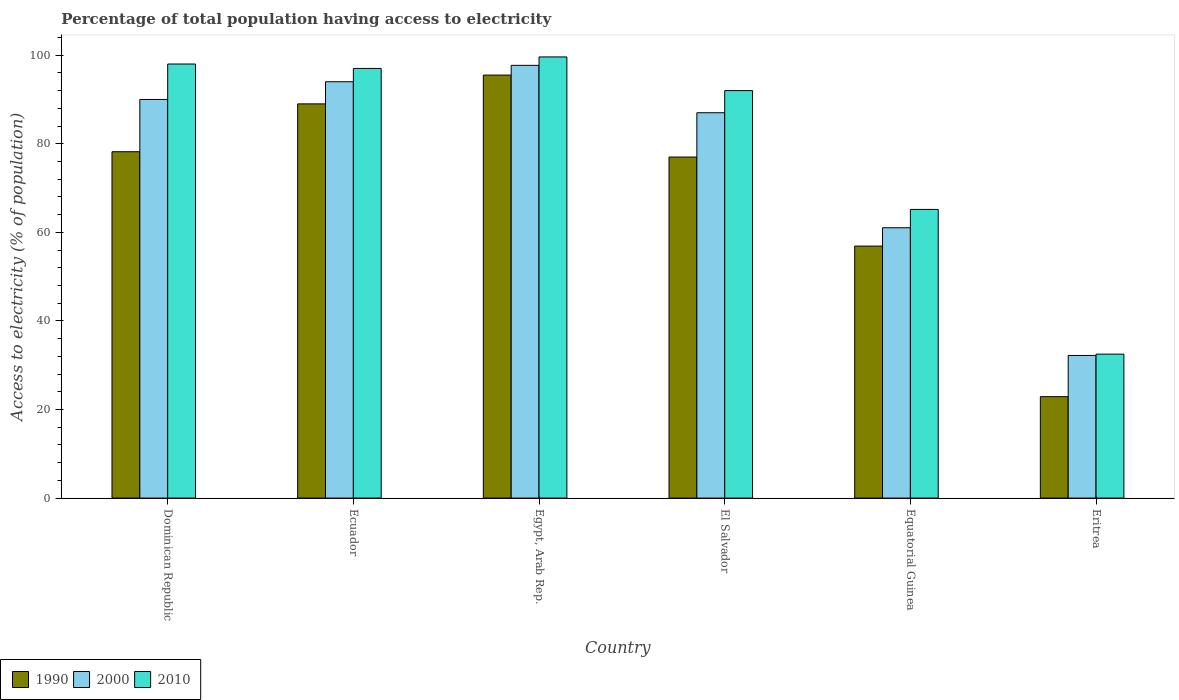How many different coloured bars are there?
Provide a succinct answer. 3. How many groups of bars are there?
Give a very brief answer. 6. Are the number of bars per tick equal to the number of legend labels?
Give a very brief answer. Yes. Are the number of bars on each tick of the X-axis equal?
Your response must be concise. Yes. How many bars are there on the 4th tick from the left?
Give a very brief answer. 3. How many bars are there on the 3rd tick from the right?
Keep it short and to the point. 3. What is the label of the 6th group of bars from the left?
Provide a short and direct response. Eritrea. In how many cases, is the number of bars for a given country not equal to the number of legend labels?
Make the answer very short. 0. What is the percentage of population that have access to electricity in 2010 in Eritrea?
Offer a terse response. 32.5. Across all countries, what is the maximum percentage of population that have access to electricity in 2000?
Keep it short and to the point. 97.7. Across all countries, what is the minimum percentage of population that have access to electricity in 1990?
Ensure brevity in your answer.  22.9. In which country was the percentage of population that have access to electricity in 2000 maximum?
Make the answer very short. Egypt, Arab Rep. In which country was the percentage of population that have access to electricity in 2010 minimum?
Your answer should be compact. Eritrea. What is the total percentage of population that have access to electricity in 2010 in the graph?
Ensure brevity in your answer.  484.27. What is the difference between the percentage of population that have access to electricity in 2000 in Dominican Republic and that in Equatorial Guinea?
Offer a very short reply. 28.97. What is the average percentage of population that have access to electricity in 2010 per country?
Offer a very short reply. 80.71. What is the difference between the percentage of population that have access to electricity of/in 2000 and percentage of population that have access to electricity of/in 1990 in El Salvador?
Give a very brief answer. 10. What is the ratio of the percentage of population that have access to electricity in 2000 in El Salvador to that in Eritrea?
Make the answer very short. 2.7. Is the percentage of population that have access to electricity in 2000 in Egypt, Arab Rep. less than that in Eritrea?
Provide a succinct answer. No. What is the difference between the highest and the second highest percentage of population that have access to electricity in 2000?
Keep it short and to the point. 7.7. What is the difference between the highest and the lowest percentage of population that have access to electricity in 1990?
Keep it short and to the point. 72.6. In how many countries, is the percentage of population that have access to electricity in 2010 greater than the average percentage of population that have access to electricity in 2010 taken over all countries?
Your answer should be compact. 4. How many bars are there?
Offer a very short reply. 18. How many countries are there in the graph?
Offer a very short reply. 6. What is the difference between two consecutive major ticks on the Y-axis?
Make the answer very short. 20. Does the graph contain any zero values?
Your response must be concise. No. How many legend labels are there?
Provide a short and direct response. 3. How are the legend labels stacked?
Ensure brevity in your answer.  Horizontal. What is the title of the graph?
Offer a very short reply. Percentage of total population having access to electricity. Does "2007" appear as one of the legend labels in the graph?
Your response must be concise. No. What is the label or title of the Y-axis?
Make the answer very short. Access to electricity (% of population). What is the Access to electricity (% of population) of 1990 in Dominican Republic?
Make the answer very short. 78.2. What is the Access to electricity (% of population) of 1990 in Ecuador?
Keep it short and to the point. 89. What is the Access to electricity (% of population) of 2000 in Ecuador?
Provide a short and direct response. 94. What is the Access to electricity (% of population) of 2010 in Ecuador?
Ensure brevity in your answer.  97. What is the Access to electricity (% of population) in 1990 in Egypt, Arab Rep.?
Ensure brevity in your answer.  95.5. What is the Access to electricity (% of population) of 2000 in Egypt, Arab Rep.?
Ensure brevity in your answer.  97.7. What is the Access to electricity (% of population) in 2010 in Egypt, Arab Rep.?
Ensure brevity in your answer.  99.6. What is the Access to electricity (% of population) in 1990 in El Salvador?
Offer a very short reply. 77. What is the Access to electricity (% of population) in 2000 in El Salvador?
Offer a terse response. 87. What is the Access to electricity (% of population) of 2010 in El Salvador?
Make the answer very short. 92. What is the Access to electricity (% of population) of 1990 in Equatorial Guinea?
Your answer should be compact. 56.89. What is the Access to electricity (% of population) in 2000 in Equatorial Guinea?
Ensure brevity in your answer.  61.03. What is the Access to electricity (% of population) of 2010 in Equatorial Guinea?
Make the answer very short. 65.17. What is the Access to electricity (% of population) of 1990 in Eritrea?
Your answer should be very brief. 22.9. What is the Access to electricity (% of population) in 2000 in Eritrea?
Your answer should be very brief. 32.2. What is the Access to electricity (% of population) of 2010 in Eritrea?
Your response must be concise. 32.5. Across all countries, what is the maximum Access to electricity (% of population) in 1990?
Offer a terse response. 95.5. Across all countries, what is the maximum Access to electricity (% of population) of 2000?
Your answer should be compact. 97.7. Across all countries, what is the maximum Access to electricity (% of population) in 2010?
Your answer should be compact. 99.6. Across all countries, what is the minimum Access to electricity (% of population) of 1990?
Your response must be concise. 22.9. Across all countries, what is the minimum Access to electricity (% of population) in 2000?
Your answer should be compact. 32.2. Across all countries, what is the minimum Access to electricity (% of population) in 2010?
Your answer should be compact. 32.5. What is the total Access to electricity (% of population) in 1990 in the graph?
Ensure brevity in your answer.  419.49. What is the total Access to electricity (% of population) of 2000 in the graph?
Ensure brevity in your answer.  461.93. What is the total Access to electricity (% of population) in 2010 in the graph?
Give a very brief answer. 484.27. What is the difference between the Access to electricity (% of population) in 1990 in Dominican Republic and that in Ecuador?
Give a very brief answer. -10.8. What is the difference between the Access to electricity (% of population) in 1990 in Dominican Republic and that in Egypt, Arab Rep.?
Provide a short and direct response. -17.3. What is the difference between the Access to electricity (% of population) of 1990 in Dominican Republic and that in El Salvador?
Offer a very short reply. 1.2. What is the difference between the Access to electricity (% of population) of 1990 in Dominican Republic and that in Equatorial Guinea?
Your answer should be compact. 21.31. What is the difference between the Access to electricity (% of population) in 2000 in Dominican Republic and that in Equatorial Guinea?
Make the answer very short. 28.97. What is the difference between the Access to electricity (% of population) of 2010 in Dominican Republic and that in Equatorial Guinea?
Ensure brevity in your answer.  32.83. What is the difference between the Access to electricity (% of population) in 1990 in Dominican Republic and that in Eritrea?
Offer a terse response. 55.3. What is the difference between the Access to electricity (% of population) in 2000 in Dominican Republic and that in Eritrea?
Your response must be concise. 57.8. What is the difference between the Access to electricity (% of population) in 2010 in Dominican Republic and that in Eritrea?
Your answer should be very brief. 65.5. What is the difference between the Access to electricity (% of population) in 2000 in Ecuador and that in Egypt, Arab Rep.?
Your answer should be compact. -3.7. What is the difference between the Access to electricity (% of population) in 2000 in Ecuador and that in El Salvador?
Give a very brief answer. 7. What is the difference between the Access to electricity (% of population) in 1990 in Ecuador and that in Equatorial Guinea?
Make the answer very short. 32.11. What is the difference between the Access to electricity (% of population) of 2000 in Ecuador and that in Equatorial Guinea?
Your response must be concise. 32.97. What is the difference between the Access to electricity (% of population) in 2010 in Ecuador and that in Equatorial Guinea?
Your answer should be very brief. 31.83. What is the difference between the Access to electricity (% of population) of 1990 in Ecuador and that in Eritrea?
Provide a succinct answer. 66.1. What is the difference between the Access to electricity (% of population) of 2000 in Ecuador and that in Eritrea?
Make the answer very short. 61.8. What is the difference between the Access to electricity (% of population) in 2010 in Ecuador and that in Eritrea?
Provide a succinct answer. 64.5. What is the difference between the Access to electricity (% of population) of 1990 in Egypt, Arab Rep. and that in El Salvador?
Make the answer very short. 18.5. What is the difference between the Access to electricity (% of population) in 2010 in Egypt, Arab Rep. and that in El Salvador?
Provide a short and direct response. 7.6. What is the difference between the Access to electricity (% of population) of 1990 in Egypt, Arab Rep. and that in Equatorial Guinea?
Provide a short and direct response. 38.61. What is the difference between the Access to electricity (% of population) in 2000 in Egypt, Arab Rep. and that in Equatorial Guinea?
Keep it short and to the point. 36.67. What is the difference between the Access to electricity (% of population) of 2010 in Egypt, Arab Rep. and that in Equatorial Guinea?
Give a very brief answer. 34.43. What is the difference between the Access to electricity (% of population) of 1990 in Egypt, Arab Rep. and that in Eritrea?
Your answer should be compact. 72.6. What is the difference between the Access to electricity (% of population) of 2000 in Egypt, Arab Rep. and that in Eritrea?
Give a very brief answer. 65.5. What is the difference between the Access to electricity (% of population) in 2010 in Egypt, Arab Rep. and that in Eritrea?
Your answer should be compact. 67.1. What is the difference between the Access to electricity (% of population) of 1990 in El Salvador and that in Equatorial Guinea?
Offer a very short reply. 20.11. What is the difference between the Access to electricity (% of population) in 2000 in El Salvador and that in Equatorial Guinea?
Provide a succinct answer. 25.97. What is the difference between the Access to electricity (% of population) of 2010 in El Salvador and that in Equatorial Guinea?
Provide a short and direct response. 26.83. What is the difference between the Access to electricity (% of population) of 1990 in El Salvador and that in Eritrea?
Provide a short and direct response. 54.1. What is the difference between the Access to electricity (% of population) in 2000 in El Salvador and that in Eritrea?
Provide a short and direct response. 54.8. What is the difference between the Access to electricity (% of population) in 2010 in El Salvador and that in Eritrea?
Your response must be concise. 59.5. What is the difference between the Access to electricity (% of population) in 1990 in Equatorial Guinea and that in Eritrea?
Your response must be concise. 33.99. What is the difference between the Access to electricity (% of population) of 2000 in Equatorial Guinea and that in Eritrea?
Provide a short and direct response. 28.83. What is the difference between the Access to electricity (% of population) in 2010 in Equatorial Guinea and that in Eritrea?
Provide a short and direct response. 32.67. What is the difference between the Access to electricity (% of population) in 1990 in Dominican Republic and the Access to electricity (% of population) in 2000 in Ecuador?
Keep it short and to the point. -15.8. What is the difference between the Access to electricity (% of population) of 1990 in Dominican Republic and the Access to electricity (% of population) of 2010 in Ecuador?
Offer a very short reply. -18.8. What is the difference between the Access to electricity (% of population) in 1990 in Dominican Republic and the Access to electricity (% of population) in 2000 in Egypt, Arab Rep.?
Make the answer very short. -19.5. What is the difference between the Access to electricity (% of population) in 1990 in Dominican Republic and the Access to electricity (% of population) in 2010 in Egypt, Arab Rep.?
Provide a short and direct response. -21.4. What is the difference between the Access to electricity (% of population) in 1990 in Dominican Republic and the Access to electricity (% of population) in 2010 in El Salvador?
Keep it short and to the point. -13.8. What is the difference between the Access to electricity (% of population) of 2000 in Dominican Republic and the Access to electricity (% of population) of 2010 in El Salvador?
Provide a short and direct response. -2. What is the difference between the Access to electricity (% of population) of 1990 in Dominican Republic and the Access to electricity (% of population) of 2000 in Equatorial Guinea?
Keep it short and to the point. 17.17. What is the difference between the Access to electricity (% of population) of 1990 in Dominican Republic and the Access to electricity (% of population) of 2010 in Equatorial Guinea?
Give a very brief answer. 13.03. What is the difference between the Access to electricity (% of population) in 2000 in Dominican Republic and the Access to electricity (% of population) in 2010 in Equatorial Guinea?
Provide a short and direct response. 24.83. What is the difference between the Access to electricity (% of population) in 1990 in Dominican Republic and the Access to electricity (% of population) in 2000 in Eritrea?
Provide a succinct answer. 46. What is the difference between the Access to electricity (% of population) in 1990 in Dominican Republic and the Access to electricity (% of population) in 2010 in Eritrea?
Offer a terse response. 45.7. What is the difference between the Access to electricity (% of population) in 2000 in Dominican Republic and the Access to electricity (% of population) in 2010 in Eritrea?
Your response must be concise. 57.5. What is the difference between the Access to electricity (% of population) of 2000 in Ecuador and the Access to electricity (% of population) of 2010 in Egypt, Arab Rep.?
Your answer should be very brief. -5.6. What is the difference between the Access to electricity (% of population) in 1990 in Ecuador and the Access to electricity (% of population) in 2000 in El Salvador?
Your answer should be very brief. 2. What is the difference between the Access to electricity (% of population) of 2000 in Ecuador and the Access to electricity (% of population) of 2010 in El Salvador?
Your response must be concise. 2. What is the difference between the Access to electricity (% of population) in 1990 in Ecuador and the Access to electricity (% of population) in 2000 in Equatorial Guinea?
Your response must be concise. 27.97. What is the difference between the Access to electricity (% of population) in 1990 in Ecuador and the Access to electricity (% of population) in 2010 in Equatorial Guinea?
Make the answer very short. 23.83. What is the difference between the Access to electricity (% of population) of 2000 in Ecuador and the Access to electricity (% of population) of 2010 in Equatorial Guinea?
Keep it short and to the point. 28.83. What is the difference between the Access to electricity (% of population) in 1990 in Ecuador and the Access to electricity (% of population) in 2000 in Eritrea?
Your answer should be compact. 56.8. What is the difference between the Access to electricity (% of population) of 1990 in Ecuador and the Access to electricity (% of population) of 2010 in Eritrea?
Offer a very short reply. 56.5. What is the difference between the Access to electricity (% of population) in 2000 in Ecuador and the Access to electricity (% of population) in 2010 in Eritrea?
Give a very brief answer. 61.5. What is the difference between the Access to electricity (% of population) in 1990 in Egypt, Arab Rep. and the Access to electricity (% of population) in 2000 in El Salvador?
Offer a very short reply. 8.5. What is the difference between the Access to electricity (% of population) in 1990 in Egypt, Arab Rep. and the Access to electricity (% of population) in 2000 in Equatorial Guinea?
Your answer should be compact. 34.47. What is the difference between the Access to electricity (% of population) in 1990 in Egypt, Arab Rep. and the Access to electricity (% of population) in 2010 in Equatorial Guinea?
Offer a very short reply. 30.33. What is the difference between the Access to electricity (% of population) of 2000 in Egypt, Arab Rep. and the Access to electricity (% of population) of 2010 in Equatorial Guinea?
Provide a succinct answer. 32.53. What is the difference between the Access to electricity (% of population) in 1990 in Egypt, Arab Rep. and the Access to electricity (% of population) in 2000 in Eritrea?
Give a very brief answer. 63.3. What is the difference between the Access to electricity (% of population) in 2000 in Egypt, Arab Rep. and the Access to electricity (% of population) in 2010 in Eritrea?
Provide a short and direct response. 65.2. What is the difference between the Access to electricity (% of population) of 1990 in El Salvador and the Access to electricity (% of population) of 2000 in Equatorial Guinea?
Provide a succinct answer. 15.97. What is the difference between the Access to electricity (% of population) in 1990 in El Salvador and the Access to electricity (% of population) in 2010 in Equatorial Guinea?
Provide a short and direct response. 11.83. What is the difference between the Access to electricity (% of population) in 2000 in El Salvador and the Access to electricity (% of population) in 2010 in Equatorial Guinea?
Your answer should be very brief. 21.83. What is the difference between the Access to electricity (% of population) in 1990 in El Salvador and the Access to electricity (% of population) in 2000 in Eritrea?
Provide a succinct answer. 44.8. What is the difference between the Access to electricity (% of population) of 1990 in El Salvador and the Access to electricity (% of population) of 2010 in Eritrea?
Offer a very short reply. 44.5. What is the difference between the Access to electricity (% of population) in 2000 in El Salvador and the Access to electricity (% of population) in 2010 in Eritrea?
Keep it short and to the point. 54.5. What is the difference between the Access to electricity (% of population) in 1990 in Equatorial Guinea and the Access to electricity (% of population) in 2000 in Eritrea?
Give a very brief answer. 24.69. What is the difference between the Access to electricity (% of population) of 1990 in Equatorial Guinea and the Access to electricity (% of population) of 2010 in Eritrea?
Your response must be concise. 24.39. What is the difference between the Access to electricity (% of population) of 2000 in Equatorial Guinea and the Access to electricity (% of population) of 2010 in Eritrea?
Offer a terse response. 28.53. What is the average Access to electricity (% of population) in 1990 per country?
Your answer should be very brief. 69.92. What is the average Access to electricity (% of population) of 2000 per country?
Your answer should be compact. 76.99. What is the average Access to electricity (% of population) of 2010 per country?
Your answer should be very brief. 80.71. What is the difference between the Access to electricity (% of population) in 1990 and Access to electricity (% of population) in 2000 in Dominican Republic?
Provide a short and direct response. -11.8. What is the difference between the Access to electricity (% of population) of 1990 and Access to electricity (% of population) of 2010 in Dominican Republic?
Provide a succinct answer. -19.8. What is the difference between the Access to electricity (% of population) of 1990 and Access to electricity (% of population) of 2000 in Ecuador?
Keep it short and to the point. -5. What is the difference between the Access to electricity (% of population) of 2000 and Access to electricity (% of population) of 2010 in Ecuador?
Keep it short and to the point. -3. What is the difference between the Access to electricity (% of population) of 1990 and Access to electricity (% of population) of 2010 in Egypt, Arab Rep.?
Provide a succinct answer. -4.1. What is the difference between the Access to electricity (% of population) of 1990 and Access to electricity (% of population) of 2010 in El Salvador?
Give a very brief answer. -15. What is the difference between the Access to electricity (% of population) of 1990 and Access to electricity (% of population) of 2000 in Equatorial Guinea?
Offer a very short reply. -4.14. What is the difference between the Access to electricity (% of population) in 1990 and Access to electricity (% of population) in 2010 in Equatorial Guinea?
Make the answer very short. -8.28. What is the difference between the Access to electricity (% of population) in 2000 and Access to electricity (% of population) in 2010 in Equatorial Guinea?
Your response must be concise. -4.14. What is the difference between the Access to electricity (% of population) of 1990 and Access to electricity (% of population) of 2000 in Eritrea?
Provide a succinct answer. -9.3. What is the difference between the Access to electricity (% of population) in 2000 and Access to electricity (% of population) in 2010 in Eritrea?
Keep it short and to the point. -0.3. What is the ratio of the Access to electricity (% of population) in 1990 in Dominican Republic to that in Ecuador?
Give a very brief answer. 0.88. What is the ratio of the Access to electricity (% of population) in 2000 in Dominican Republic to that in Ecuador?
Your response must be concise. 0.96. What is the ratio of the Access to electricity (% of population) of 2010 in Dominican Republic to that in Ecuador?
Ensure brevity in your answer.  1.01. What is the ratio of the Access to electricity (% of population) of 1990 in Dominican Republic to that in Egypt, Arab Rep.?
Your answer should be very brief. 0.82. What is the ratio of the Access to electricity (% of population) in 2000 in Dominican Republic to that in Egypt, Arab Rep.?
Keep it short and to the point. 0.92. What is the ratio of the Access to electricity (% of population) in 2010 in Dominican Republic to that in Egypt, Arab Rep.?
Ensure brevity in your answer.  0.98. What is the ratio of the Access to electricity (% of population) of 1990 in Dominican Republic to that in El Salvador?
Give a very brief answer. 1.02. What is the ratio of the Access to electricity (% of population) of 2000 in Dominican Republic to that in El Salvador?
Give a very brief answer. 1.03. What is the ratio of the Access to electricity (% of population) of 2010 in Dominican Republic to that in El Salvador?
Offer a terse response. 1.07. What is the ratio of the Access to electricity (% of population) in 1990 in Dominican Republic to that in Equatorial Guinea?
Ensure brevity in your answer.  1.37. What is the ratio of the Access to electricity (% of population) in 2000 in Dominican Republic to that in Equatorial Guinea?
Provide a succinct answer. 1.47. What is the ratio of the Access to electricity (% of population) in 2010 in Dominican Republic to that in Equatorial Guinea?
Give a very brief answer. 1.5. What is the ratio of the Access to electricity (% of population) of 1990 in Dominican Republic to that in Eritrea?
Offer a terse response. 3.41. What is the ratio of the Access to electricity (% of population) of 2000 in Dominican Republic to that in Eritrea?
Provide a succinct answer. 2.79. What is the ratio of the Access to electricity (% of population) in 2010 in Dominican Republic to that in Eritrea?
Ensure brevity in your answer.  3.02. What is the ratio of the Access to electricity (% of population) of 1990 in Ecuador to that in Egypt, Arab Rep.?
Give a very brief answer. 0.93. What is the ratio of the Access to electricity (% of population) in 2000 in Ecuador to that in Egypt, Arab Rep.?
Give a very brief answer. 0.96. What is the ratio of the Access to electricity (% of population) of 2010 in Ecuador to that in Egypt, Arab Rep.?
Keep it short and to the point. 0.97. What is the ratio of the Access to electricity (% of population) in 1990 in Ecuador to that in El Salvador?
Keep it short and to the point. 1.16. What is the ratio of the Access to electricity (% of population) of 2000 in Ecuador to that in El Salvador?
Give a very brief answer. 1.08. What is the ratio of the Access to electricity (% of population) in 2010 in Ecuador to that in El Salvador?
Ensure brevity in your answer.  1.05. What is the ratio of the Access to electricity (% of population) in 1990 in Ecuador to that in Equatorial Guinea?
Your answer should be very brief. 1.56. What is the ratio of the Access to electricity (% of population) of 2000 in Ecuador to that in Equatorial Guinea?
Keep it short and to the point. 1.54. What is the ratio of the Access to electricity (% of population) of 2010 in Ecuador to that in Equatorial Guinea?
Offer a terse response. 1.49. What is the ratio of the Access to electricity (% of population) in 1990 in Ecuador to that in Eritrea?
Your response must be concise. 3.89. What is the ratio of the Access to electricity (% of population) of 2000 in Ecuador to that in Eritrea?
Provide a short and direct response. 2.92. What is the ratio of the Access to electricity (% of population) in 2010 in Ecuador to that in Eritrea?
Ensure brevity in your answer.  2.98. What is the ratio of the Access to electricity (% of population) of 1990 in Egypt, Arab Rep. to that in El Salvador?
Your answer should be very brief. 1.24. What is the ratio of the Access to electricity (% of population) of 2000 in Egypt, Arab Rep. to that in El Salvador?
Your answer should be very brief. 1.12. What is the ratio of the Access to electricity (% of population) in 2010 in Egypt, Arab Rep. to that in El Salvador?
Offer a terse response. 1.08. What is the ratio of the Access to electricity (% of population) in 1990 in Egypt, Arab Rep. to that in Equatorial Guinea?
Provide a short and direct response. 1.68. What is the ratio of the Access to electricity (% of population) in 2000 in Egypt, Arab Rep. to that in Equatorial Guinea?
Your response must be concise. 1.6. What is the ratio of the Access to electricity (% of population) in 2010 in Egypt, Arab Rep. to that in Equatorial Guinea?
Your answer should be very brief. 1.53. What is the ratio of the Access to electricity (% of population) in 1990 in Egypt, Arab Rep. to that in Eritrea?
Give a very brief answer. 4.17. What is the ratio of the Access to electricity (% of population) in 2000 in Egypt, Arab Rep. to that in Eritrea?
Your answer should be very brief. 3.03. What is the ratio of the Access to electricity (% of population) of 2010 in Egypt, Arab Rep. to that in Eritrea?
Provide a succinct answer. 3.06. What is the ratio of the Access to electricity (% of population) in 1990 in El Salvador to that in Equatorial Guinea?
Your answer should be very brief. 1.35. What is the ratio of the Access to electricity (% of population) in 2000 in El Salvador to that in Equatorial Guinea?
Make the answer very short. 1.43. What is the ratio of the Access to electricity (% of population) in 2010 in El Salvador to that in Equatorial Guinea?
Provide a short and direct response. 1.41. What is the ratio of the Access to electricity (% of population) in 1990 in El Salvador to that in Eritrea?
Keep it short and to the point. 3.36. What is the ratio of the Access to electricity (% of population) of 2000 in El Salvador to that in Eritrea?
Keep it short and to the point. 2.7. What is the ratio of the Access to electricity (% of population) of 2010 in El Salvador to that in Eritrea?
Ensure brevity in your answer.  2.83. What is the ratio of the Access to electricity (% of population) of 1990 in Equatorial Guinea to that in Eritrea?
Offer a terse response. 2.48. What is the ratio of the Access to electricity (% of population) in 2000 in Equatorial Guinea to that in Eritrea?
Offer a very short reply. 1.9. What is the ratio of the Access to electricity (% of population) in 2010 in Equatorial Guinea to that in Eritrea?
Ensure brevity in your answer.  2.01. What is the difference between the highest and the second highest Access to electricity (% of population) of 2000?
Provide a succinct answer. 3.7. What is the difference between the highest and the second highest Access to electricity (% of population) of 2010?
Your answer should be compact. 1.6. What is the difference between the highest and the lowest Access to electricity (% of population) in 1990?
Offer a terse response. 72.6. What is the difference between the highest and the lowest Access to electricity (% of population) of 2000?
Offer a very short reply. 65.5. What is the difference between the highest and the lowest Access to electricity (% of population) of 2010?
Keep it short and to the point. 67.1. 